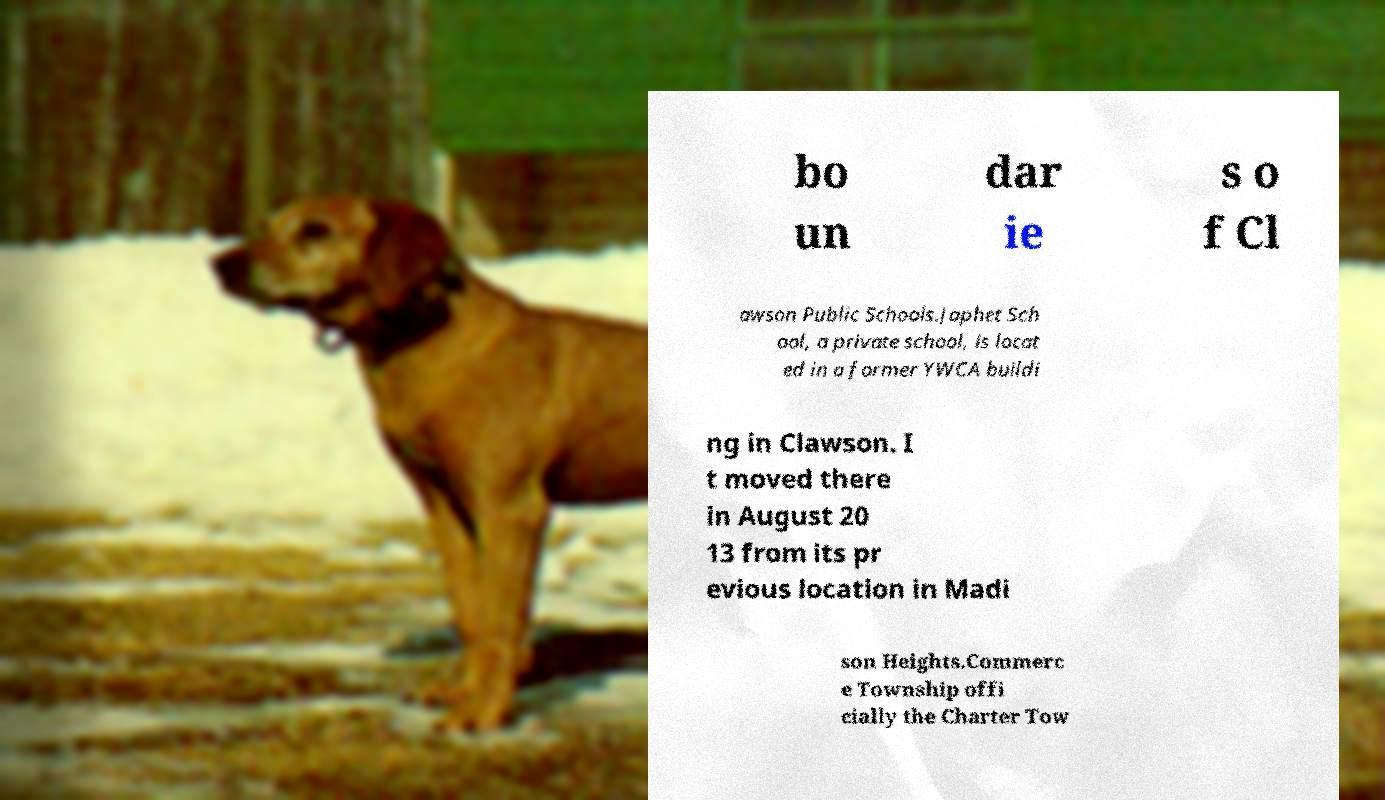I need the written content from this picture converted into text. Can you do that? bo un dar ie s o f Cl awson Public Schools.Japhet Sch ool, a private school, is locat ed in a former YWCA buildi ng in Clawson. I t moved there in August 20 13 from its pr evious location in Madi son Heights.Commerc e Township offi cially the Charter Tow 